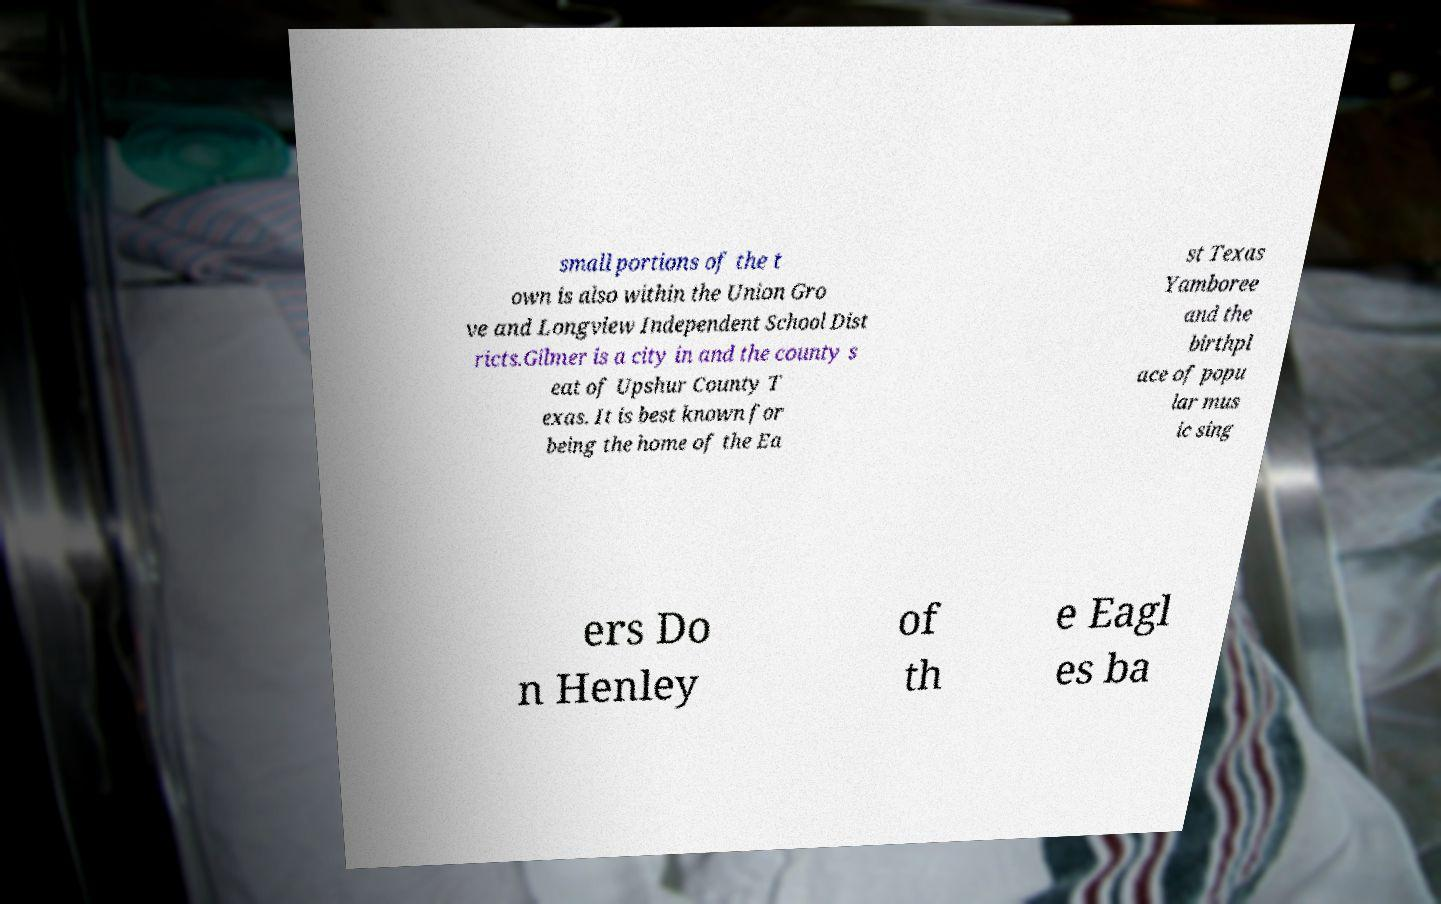Please identify and transcribe the text found in this image. small portions of the t own is also within the Union Gro ve and Longview Independent School Dist ricts.Gilmer is a city in and the county s eat of Upshur County T exas. It is best known for being the home of the Ea st Texas Yamboree and the birthpl ace of popu lar mus ic sing ers Do n Henley of th e Eagl es ba 